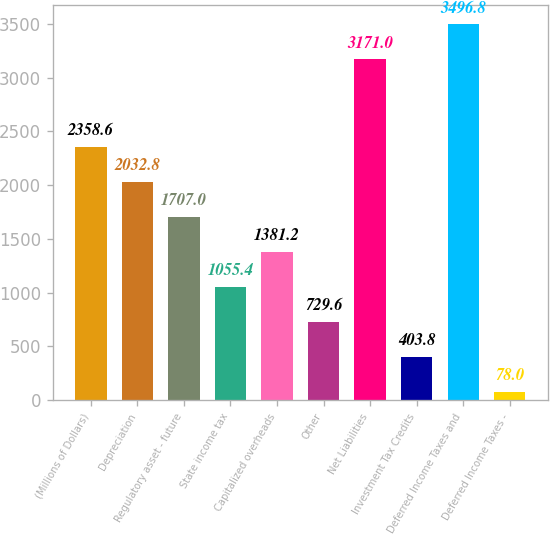Convert chart to OTSL. <chart><loc_0><loc_0><loc_500><loc_500><bar_chart><fcel>(Millions of Dollars)<fcel>Depreciation<fcel>Regulatory asset - future<fcel>State income tax<fcel>Capitalized overheads<fcel>Other<fcel>Net Liabilities<fcel>Investment Tax Credits<fcel>Deferred Income Taxes and<fcel>Deferred Income Taxes -<nl><fcel>2358.6<fcel>2032.8<fcel>1707<fcel>1055.4<fcel>1381.2<fcel>729.6<fcel>3171<fcel>403.8<fcel>3496.8<fcel>78<nl></chart> 